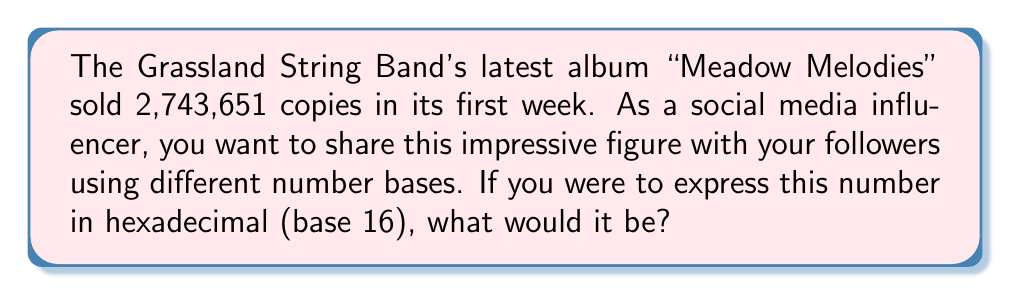Show me your answer to this math problem. To convert the decimal number 2,743,651 to hexadecimal, we need to repeatedly divide by 16 and keep track of the remainders. The remainders, read from bottom to top, will give us the hexadecimal representation.

$$\begin{align}
2,743,651 \div 16 &= 171,478 \text{ remainder } 3 \\
171,478 \div 16 &= 10,717 \text{ remainder } 6 \\
10,717 \div 16 &= 669 \text{ remainder } 13 \text{ (D in hex)} \\
669 \div 16 &= 41 \text{ remainder } 13 \text{ (D in hex)} \\
41 \div 16 &= 2 \text{ remainder } 9 \\
2 \div 16 &= 0 \text{ remainder } 2
\end{align}$$

Reading the remainders from bottom to top, we get:

$$2 \rightarrow 9 \rightarrow \text{D} \rightarrow \text{D} \rightarrow 6 \rightarrow 3$$

Therefore, the hexadecimal representation of 2,743,651 is 29DD63.
Answer: 29DD63 (hexadecimal) 